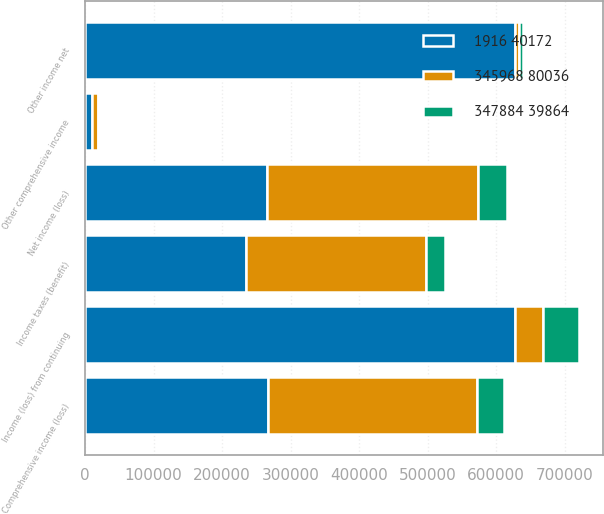<chart> <loc_0><loc_0><loc_500><loc_500><stacked_bar_chart><ecel><fcel>Net income (loss)<fcel>Other comprehensive income<fcel>Comprehensive income (loss)<fcel>Other income net<fcel>Income (loss) from continuing<fcel>Income taxes (benefit)<nl><fcel>1916 40172<fcel>265932<fcel>9555<fcel>266844<fcel>627703<fcel>627703<fcel>235156<nl><fcel>347884 39864<fcel>42088<fcel>163<fcel>39003<fcel>5503<fcel>51989<fcel>27774<nl><fcel>345968 80036<fcel>308020<fcel>9392<fcel>305847<fcel>5861<fcel>40545.5<fcel>262930<nl></chart> 